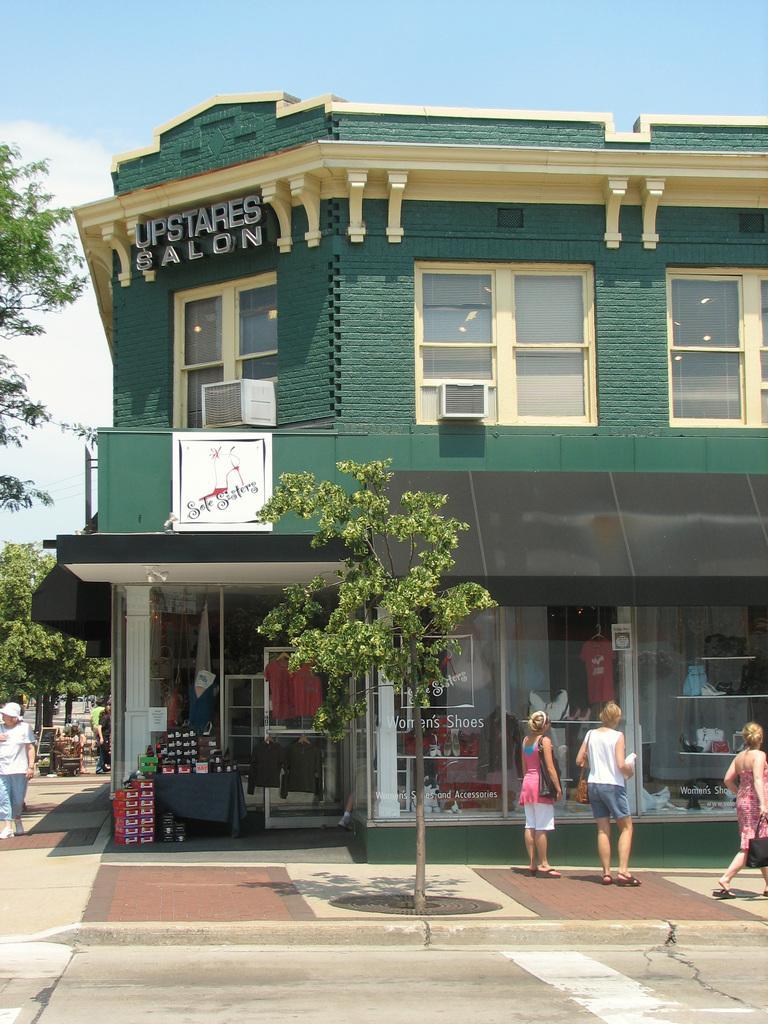How would you summarize this image in a sentence or two? In the middle of the image we can see a tree. Behind the tree few people are standing and walking. Behind them there is a building. Behind the building there are some trees. At the top of the image there are some clouds and sky. 